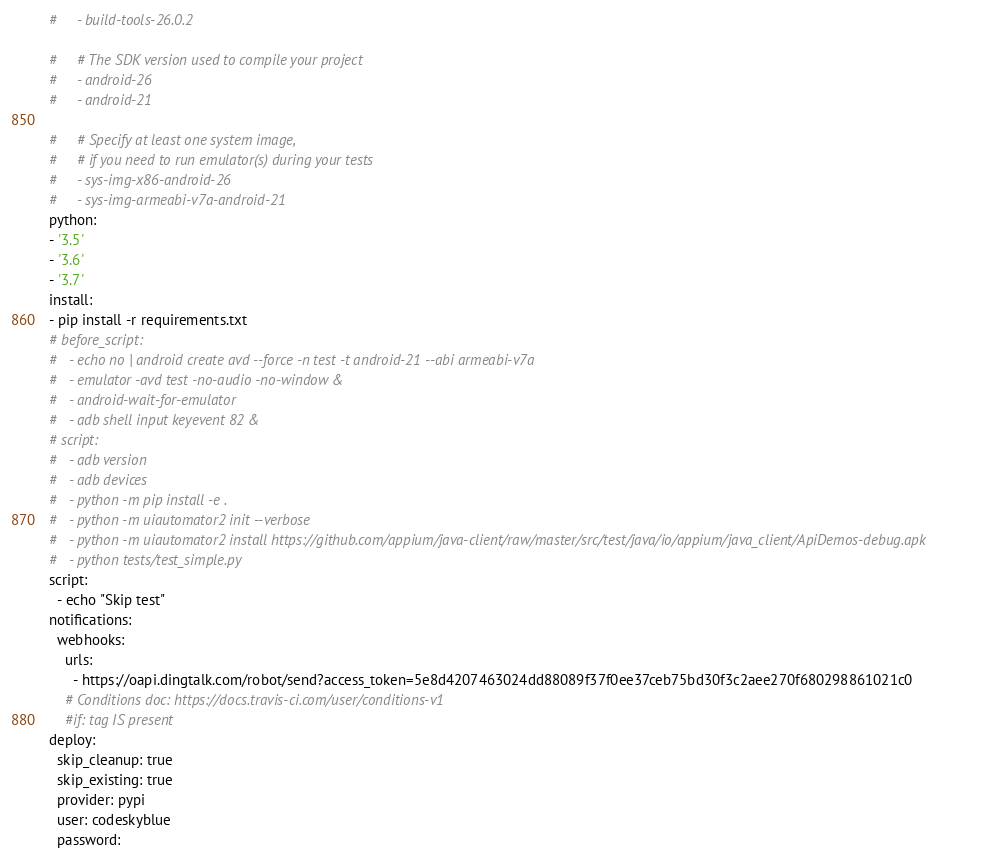<code> <loc_0><loc_0><loc_500><loc_500><_YAML_>#     - build-tools-26.0.2

#     # The SDK version used to compile your project
#     - android-26
#     - android-21

#     # Specify at least one system image,
#     # if you need to run emulator(s) during your tests
#     - sys-img-x86-android-26
#     - sys-img-armeabi-v7a-android-21
python:
- '3.5'
- '3.6'
- '3.7'
install:
- pip install -r requirements.txt
# before_script:
#   - echo no | android create avd --force -n test -t android-21 --abi armeabi-v7a
#   - emulator -avd test -no-audio -no-window &
#   - android-wait-for-emulator
#   - adb shell input keyevent 82 &
# script:
#   - adb version
#   - adb devices
#   - python -m pip install -e .
#   - python -m uiautomator2 init --verbose
#   - python -m uiautomator2 install https://github.com/appium/java-client/raw/master/src/test/java/io/appium/java_client/ApiDemos-debug.apk
#   - python tests/test_simple.py
script:
  - echo "Skip test"
notifications:
  webhooks:
    urls:
      - https://oapi.dingtalk.com/robot/send?access_token=5e8d4207463024dd88089f37f0ee37ceb75bd30f3c2aee270f680298861021c0
    # Conditions doc: https://docs.travis-ci.com/user/conditions-v1
    #if: tag IS present
deploy:
  skip_cleanup: true
  skip_existing: true
  provider: pypi
  user: codeskyblue
  password:</code> 